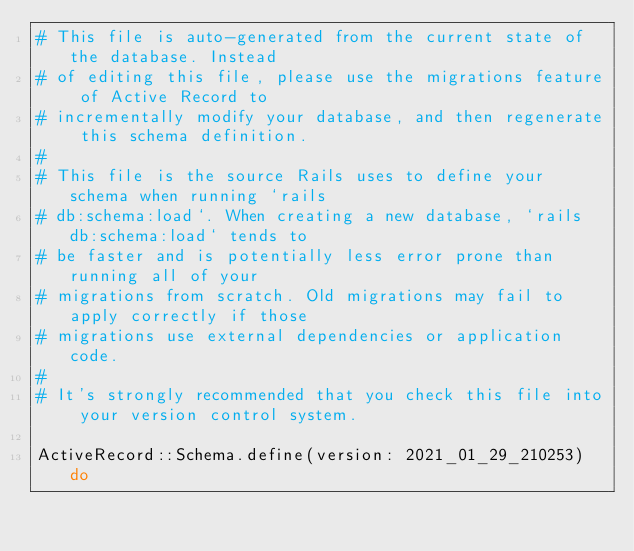<code> <loc_0><loc_0><loc_500><loc_500><_Ruby_># This file is auto-generated from the current state of the database. Instead
# of editing this file, please use the migrations feature of Active Record to
# incrementally modify your database, and then regenerate this schema definition.
#
# This file is the source Rails uses to define your schema when running `rails
# db:schema:load`. When creating a new database, `rails db:schema:load` tends to
# be faster and is potentially less error prone than running all of your
# migrations from scratch. Old migrations may fail to apply correctly if those
# migrations use external dependencies or application code.
#
# It's strongly recommended that you check this file into your version control system.

ActiveRecord::Schema.define(version: 2021_01_29_210253) do
</code> 